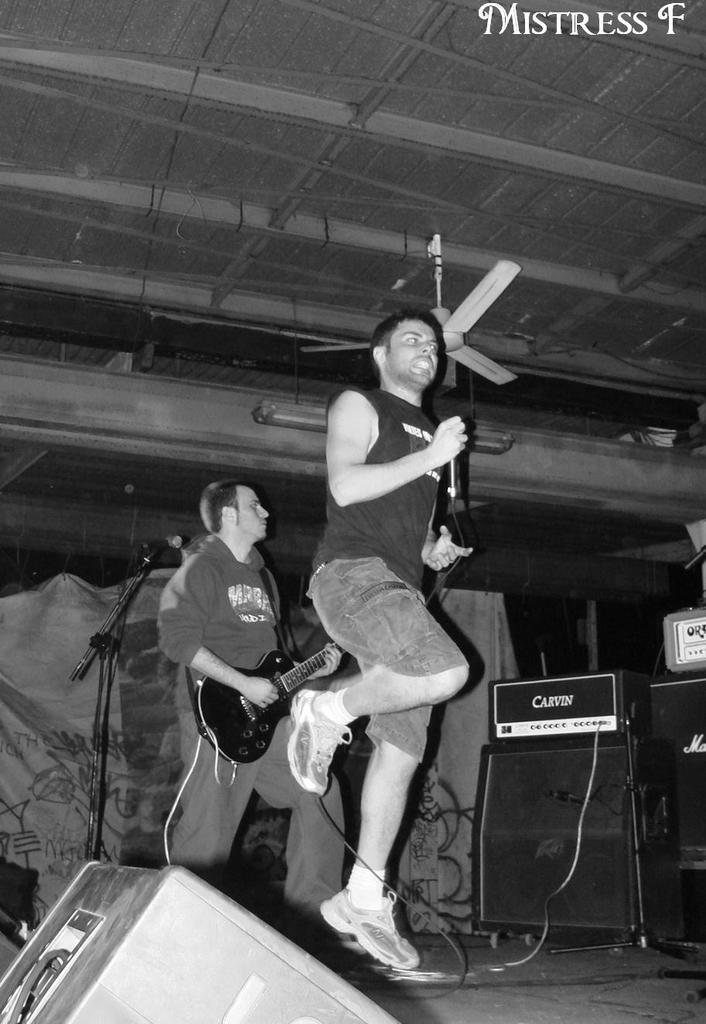What is the man in the image doing? There is a man playing a guitar in the image. What is the other man in the image doing? There is a man jumping in the image. What object can be seen in the image that might provide air circulation? There is a fan in the image. What type of voice can be heard singing along with the guitar in the image? There is no voice or singing present in the image; only the man playing the guitar can be seen. Is there a girl in the image playing with the fan? There is no girl present in the image; only two men and a fan can be seen. 